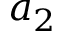<formula> <loc_0><loc_0><loc_500><loc_500>a _ { 2 }</formula> 